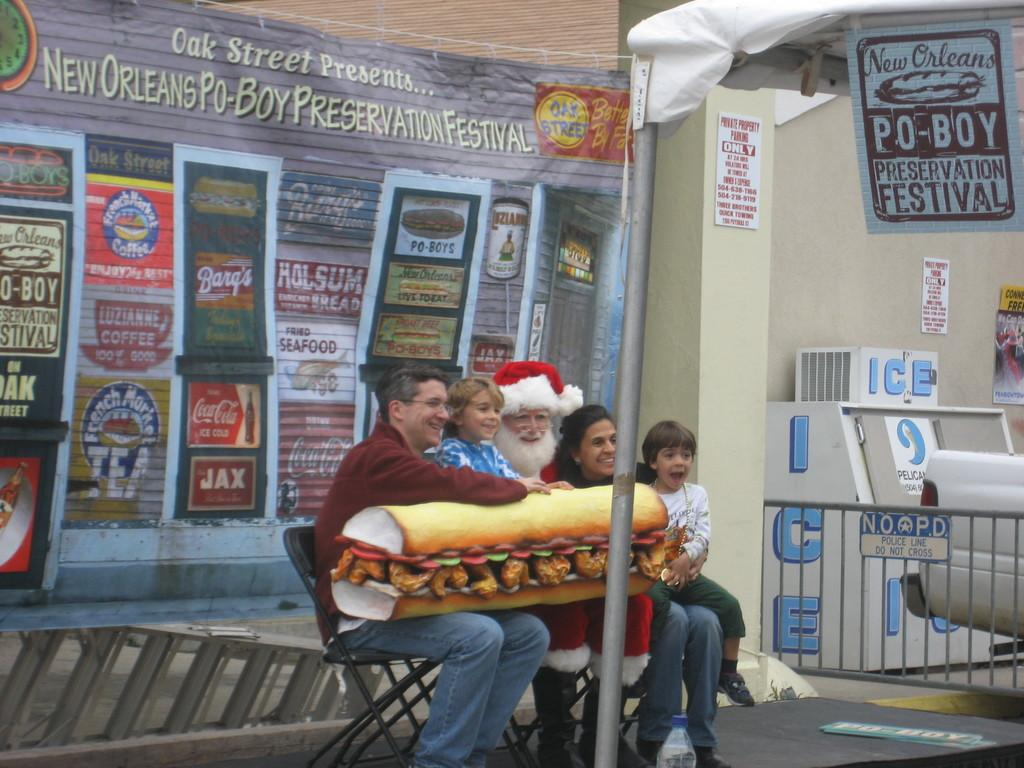How many people are in the image? There are two men and some kids in the image. What are the men and kids doing in the image? They are sitting on chairs and holding a big burger in their hands. What can be seen in the background of the image? There is a poster and a wall in the background of the image. What type of architectural feature is present in the image? There is a fencing in the image. What type of branch is the man holding in the image? There is no branch present in the image; the men and kids are holding a big burger. How does the man feel shame in the image? There is no indication of shame in the image; the men and kids are simply sitting and holding a burger. 